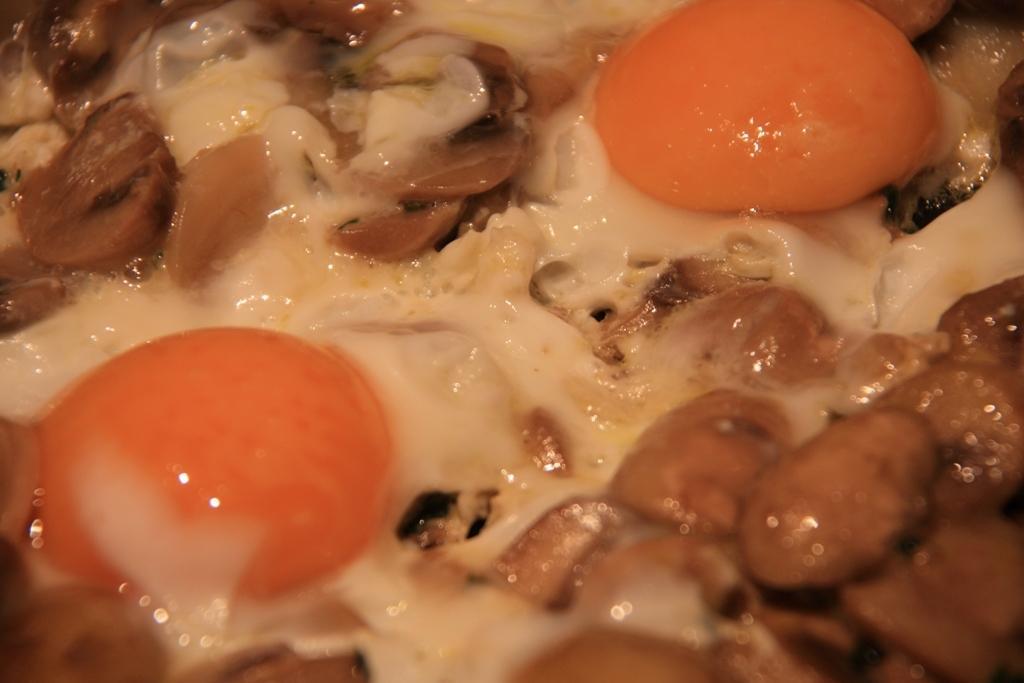In one or two sentences, can you explain what this image depicts? It is a zoomed in picture of a food item with the eggs. 